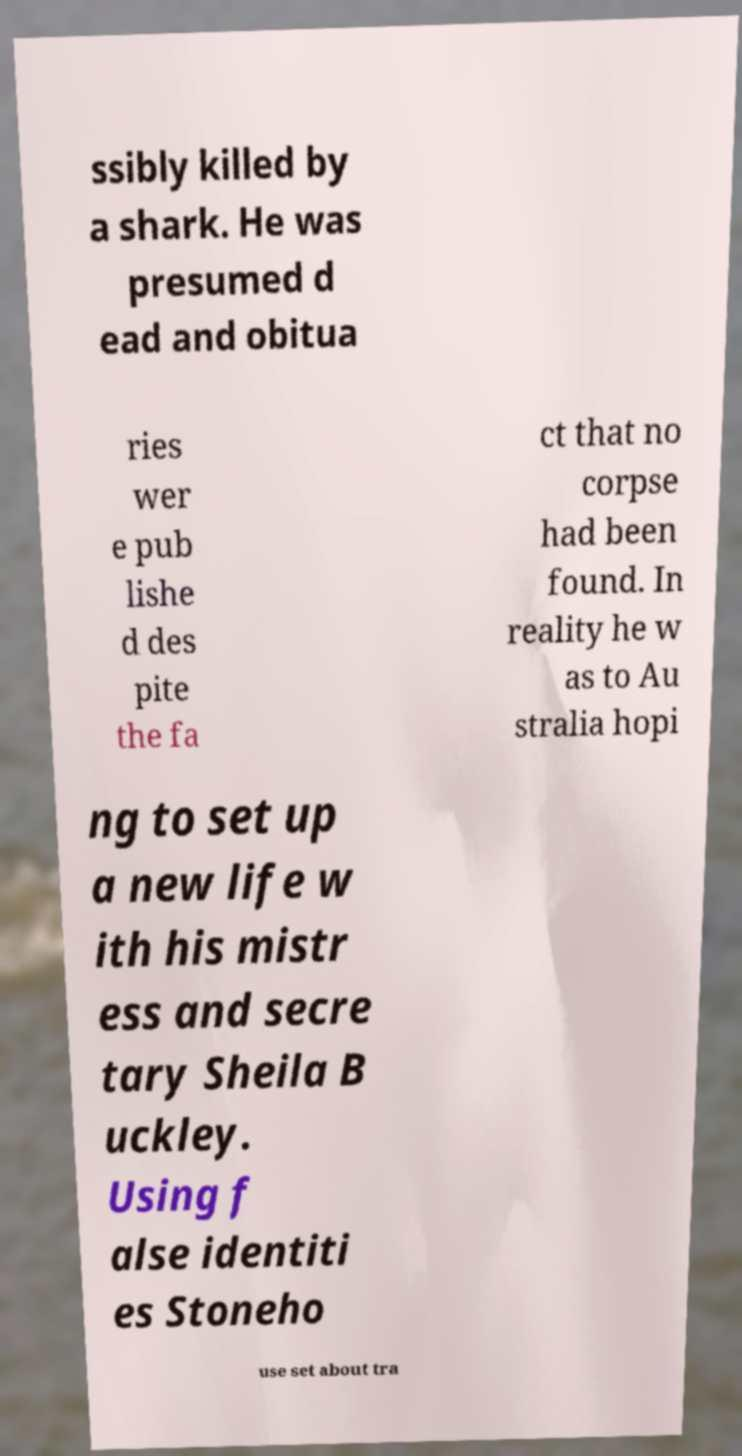There's text embedded in this image that I need extracted. Can you transcribe it verbatim? ssibly killed by a shark. He was presumed d ead and obitua ries wer e pub lishe d des pite the fa ct that no corpse had been found. In reality he w as to Au stralia hopi ng to set up a new life w ith his mistr ess and secre tary Sheila B uckley. Using f alse identiti es Stoneho use set about tra 